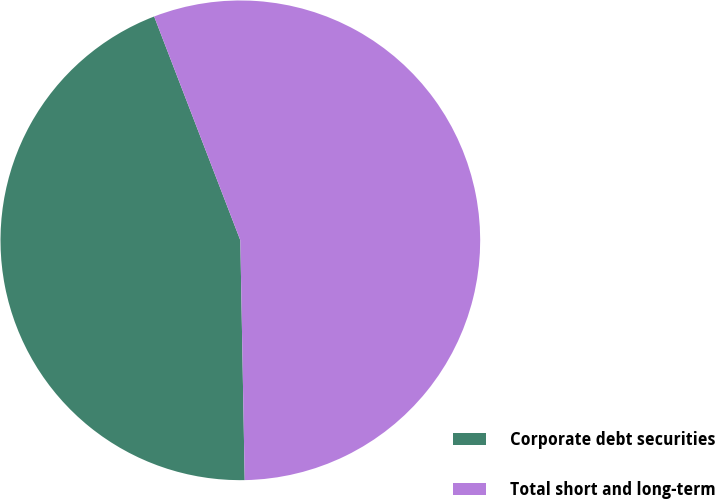<chart> <loc_0><loc_0><loc_500><loc_500><pie_chart><fcel>Corporate debt securities<fcel>Total short and long-term<nl><fcel>44.44%<fcel>55.56%<nl></chart> 